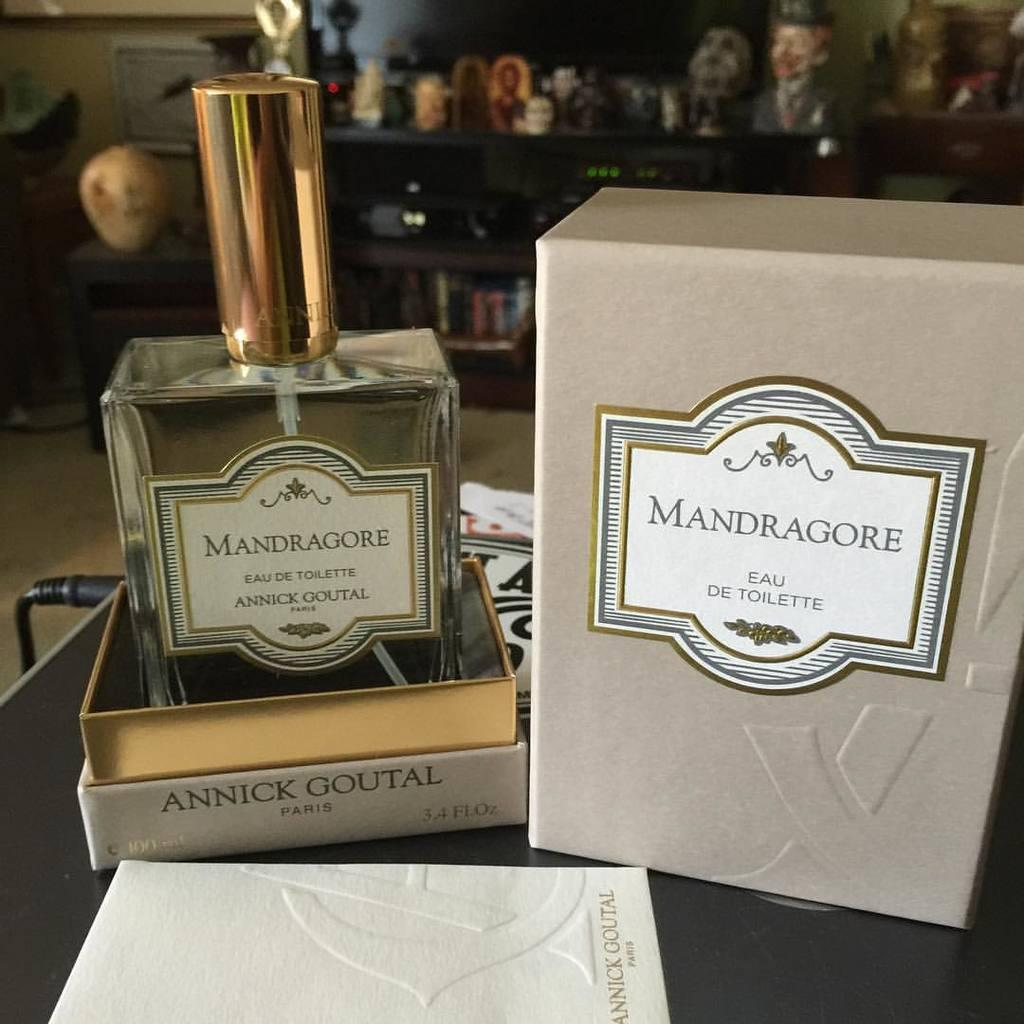Provide a one-sentence caption for the provided image. Box of Mandragore eau de toilette and Mandragore paris. 